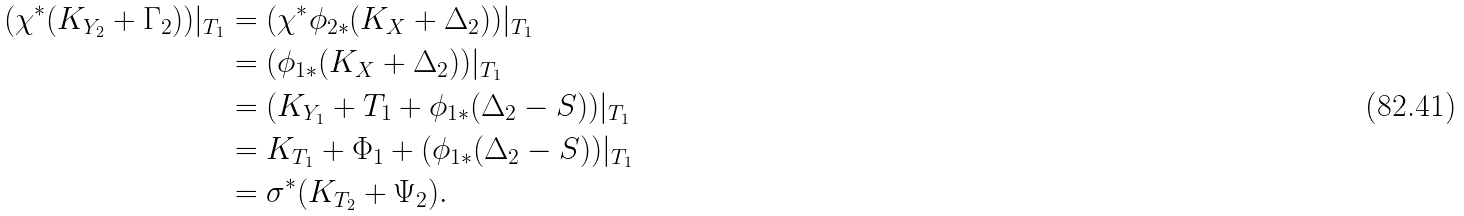Convert formula to latex. <formula><loc_0><loc_0><loc_500><loc_500>( \chi ^ { * } ( K _ { Y _ { 2 } } + \Gamma _ { 2 } ) ) | _ { T _ { 1 } } & = ( \chi ^ { * } \phi _ { 2 * } ( K _ { X } + \Delta _ { 2 } ) ) | _ { T _ { 1 } } \\ & = ( \phi _ { 1 * } ( K _ { X } + \Delta _ { 2 } ) ) | _ { T _ { 1 } } \\ & = ( K _ { Y _ { 1 } } + T _ { 1 } + \phi _ { 1 * } ( \Delta _ { 2 } - S ) ) | _ { T _ { 1 } } \\ & = K _ { T _ { 1 } } + \Phi _ { 1 } + ( \phi _ { 1 * } ( \Delta _ { 2 } - S ) ) | _ { T _ { 1 } } \\ & = \sigma ^ { * } ( K _ { T _ { 2 } } + \Psi _ { 2 } ) .</formula> 